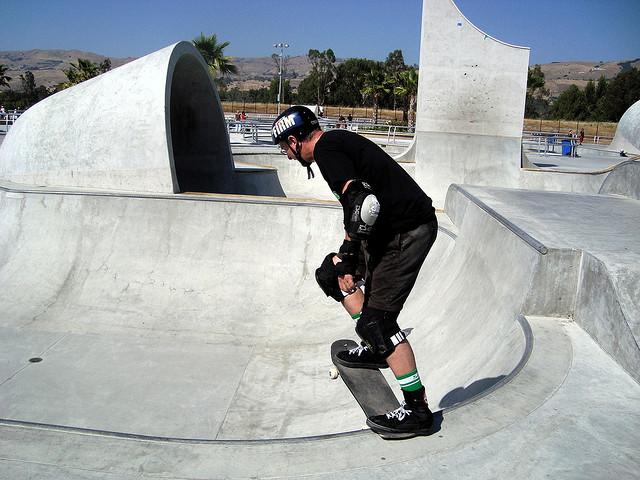What is the man doing?
Keep it brief. Skateboarding. What protective gear is the man wearing on his arms?
Concise answer only. Elbow pads. Does this skater have on cleats?
Be succinct. No. 